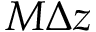<formula> <loc_0><loc_0><loc_500><loc_500>M \Delta z</formula> 